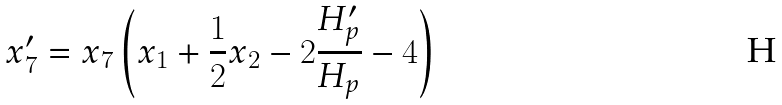Convert formula to latex. <formula><loc_0><loc_0><loc_500><loc_500>x ^ { \prime } _ { 7 } = x _ { 7 } \left ( x _ { 1 } + \frac { 1 } { 2 } x _ { 2 } - 2 \frac { H ^ { \prime } _ { p } } { H _ { p } } - 4 \right )</formula> 